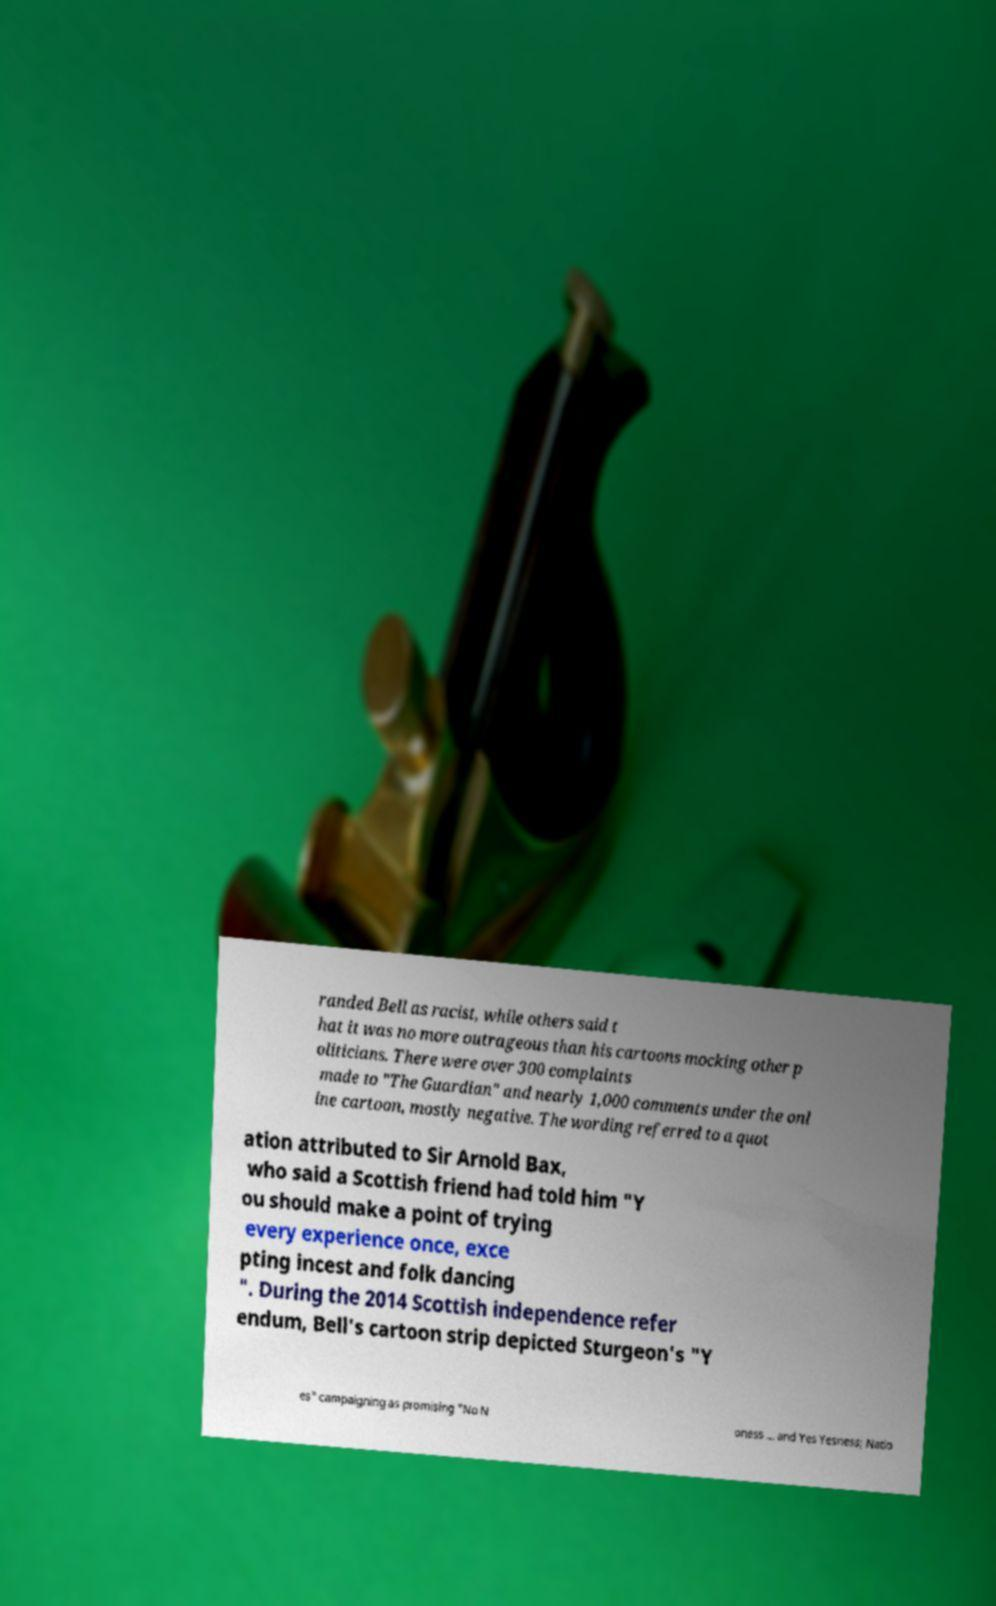Can you read and provide the text displayed in the image?This photo seems to have some interesting text. Can you extract and type it out for me? randed Bell as racist, while others said t hat it was no more outrageous than his cartoons mocking other p oliticians. There were over 300 complaints made to "The Guardian" and nearly 1,000 comments under the onl ine cartoon, mostly negative. The wording referred to a quot ation attributed to Sir Arnold Bax, who said a Scottish friend had told him "Y ou should make a point of trying every experience once, exce pting incest and folk dancing ". During the 2014 Scottish independence refer endum, Bell's cartoon strip depicted Sturgeon's "Y es" campaigning as promising "No N oness ... and Yes Yesness; Natio 